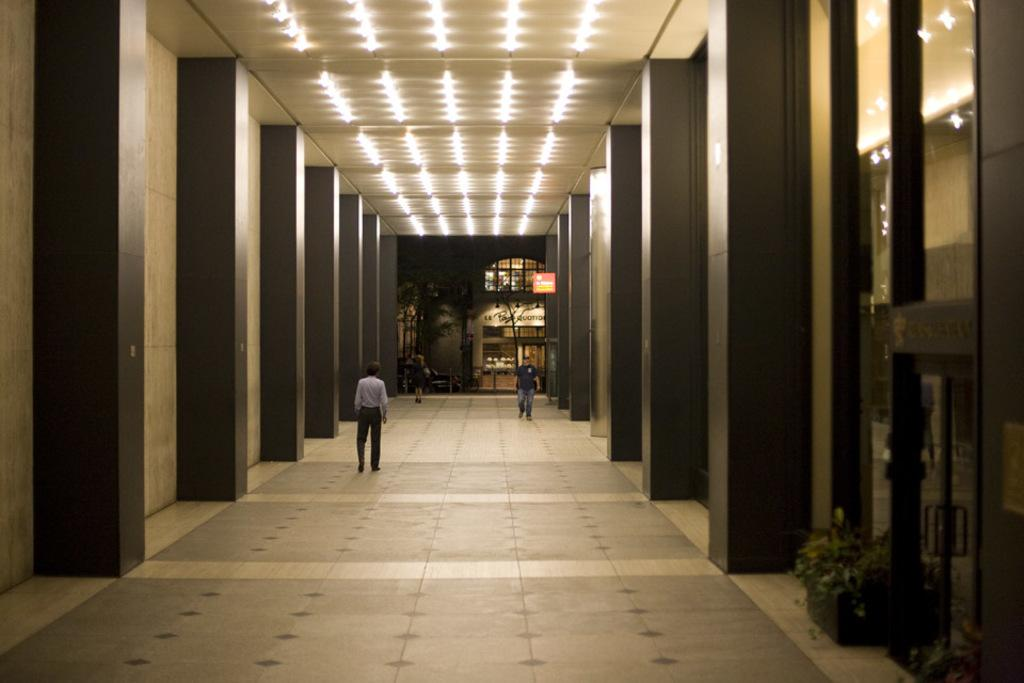How many people are walking in the building in the image? There are three people walking in the building in the image. What can be seen behind the building? Trees are visible behind the building. What else can be seen beyond the trees? There is another building visible behind the trees. What type of shoes are the people wearing in the image? There is no information about the shoes the people are wearing in the image. 